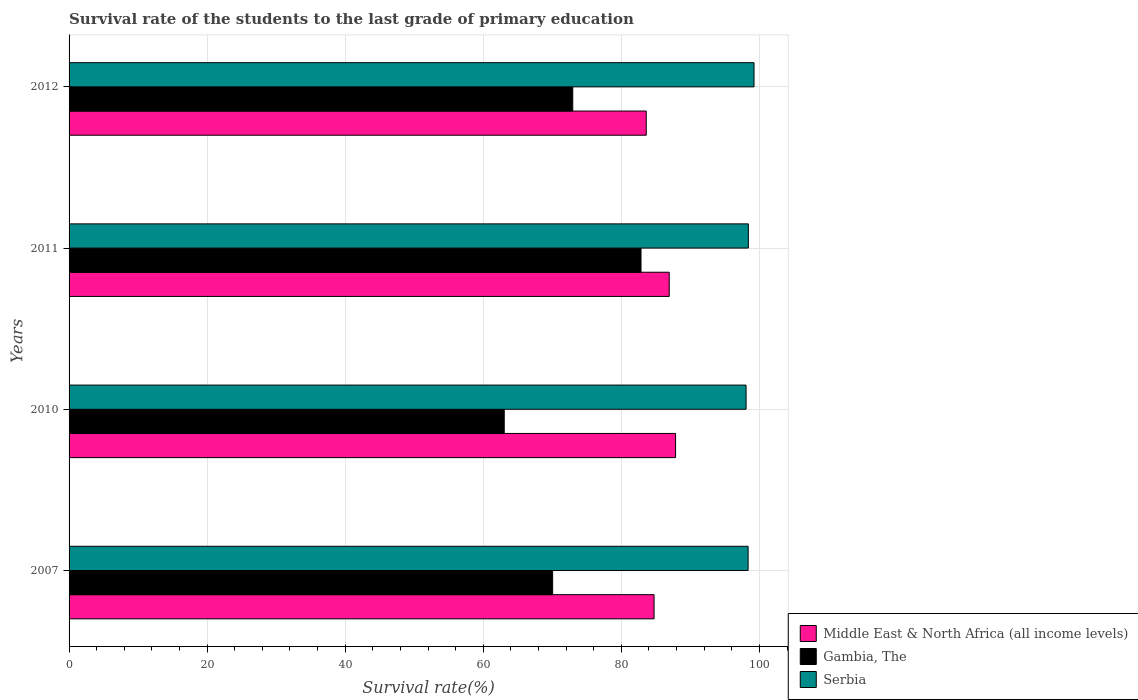How many different coloured bars are there?
Your answer should be very brief. 3. How many groups of bars are there?
Your answer should be very brief. 4. How many bars are there on the 1st tick from the bottom?
Make the answer very short. 3. What is the survival rate of the students in Middle East & North Africa (all income levels) in 2007?
Keep it short and to the point. 84.74. Across all years, what is the maximum survival rate of the students in Middle East & North Africa (all income levels)?
Offer a terse response. 87.86. Across all years, what is the minimum survival rate of the students in Middle East & North Africa (all income levels)?
Provide a short and direct response. 83.61. In which year was the survival rate of the students in Gambia, The maximum?
Your answer should be compact. 2011. In which year was the survival rate of the students in Gambia, The minimum?
Give a very brief answer. 2010. What is the total survival rate of the students in Middle East & North Africa (all income levels) in the graph?
Provide a succinct answer. 343.14. What is the difference between the survival rate of the students in Gambia, The in 2010 and that in 2011?
Provide a short and direct response. -19.81. What is the difference between the survival rate of the students in Serbia in 2011 and the survival rate of the students in Gambia, The in 2007?
Your answer should be compact. 28.35. What is the average survival rate of the students in Gambia, The per year?
Make the answer very short. 72.22. In the year 2007, what is the difference between the survival rate of the students in Middle East & North Africa (all income levels) and survival rate of the students in Gambia, The?
Provide a short and direct response. 14.69. In how many years, is the survival rate of the students in Gambia, The greater than 4 %?
Ensure brevity in your answer.  4. What is the ratio of the survival rate of the students in Middle East & North Africa (all income levels) in 2007 to that in 2010?
Provide a succinct answer. 0.96. What is the difference between the highest and the second highest survival rate of the students in Serbia?
Your answer should be very brief. 0.82. What is the difference between the highest and the lowest survival rate of the students in Middle East & North Africa (all income levels)?
Give a very brief answer. 4.25. In how many years, is the survival rate of the students in Gambia, The greater than the average survival rate of the students in Gambia, The taken over all years?
Provide a succinct answer. 2. Is the sum of the survival rate of the students in Gambia, The in 2011 and 2012 greater than the maximum survival rate of the students in Serbia across all years?
Offer a very short reply. Yes. What does the 3rd bar from the top in 2010 represents?
Make the answer very short. Middle East & North Africa (all income levels). What does the 2nd bar from the bottom in 2010 represents?
Your answer should be very brief. Gambia, The. How many bars are there?
Keep it short and to the point. 12. Are all the bars in the graph horizontal?
Your answer should be very brief. Yes. How many years are there in the graph?
Give a very brief answer. 4. What is the difference between two consecutive major ticks on the X-axis?
Your response must be concise. 20. Does the graph contain any zero values?
Give a very brief answer. No. How many legend labels are there?
Make the answer very short. 3. How are the legend labels stacked?
Your answer should be compact. Vertical. What is the title of the graph?
Provide a succinct answer. Survival rate of the students to the last grade of primary education. What is the label or title of the X-axis?
Offer a terse response. Survival rate(%). What is the Survival rate(%) in Middle East & North Africa (all income levels) in 2007?
Offer a terse response. 84.74. What is the Survival rate(%) in Gambia, The in 2007?
Your response must be concise. 70.05. What is the Survival rate(%) of Serbia in 2007?
Offer a terse response. 98.36. What is the Survival rate(%) of Middle East & North Africa (all income levels) in 2010?
Offer a terse response. 87.86. What is the Survival rate(%) in Gambia, The in 2010?
Keep it short and to the point. 63.04. What is the Survival rate(%) in Serbia in 2010?
Offer a terse response. 98.07. What is the Survival rate(%) of Middle East & North Africa (all income levels) in 2011?
Your response must be concise. 86.94. What is the Survival rate(%) of Gambia, The in 2011?
Provide a succinct answer. 82.85. What is the Survival rate(%) of Serbia in 2011?
Ensure brevity in your answer.  98.4. What is the Survival rate(%) of Middle East & North Africa (all income levels) in 2012?
Your response must be concise. 83.61. What is the Survival rate(%) in Gambia, The in 2012?
Make the answer very short. 72.96. What is the Survival rate(%) in Serbia in 2012?
Provide a short and direct response. 99.22. Across all years, what is the maximum Survival rate(%) of Middle East & North Africa (all income levels)?
Your response must be concise. 87.86. Across all years, what is the maximum Survival rate(%) of Gambia, The?
Give a very brief answer. 82.85. Across all years, what is the maximum Survival rate(%) of Serbia?
Make the answer very short. 99.22. Across all years, what is the minimum Survival rate(%) in Middle East & North Africa (all income levels)?
Your answer should be compact. 83.61. Across all years, what is the minimum Survival rate(%) in Gambia, The?
Offer a very short reply. 63.04. Across all years, what is the minimum Survival rate(%) of Serbia?
Provide a succinct answer. 98.07. What is the total Survival rate(%) in Middle East & North Africa (all income levels) in the graph?
Ensure brevity in your answer.  343.14. What is the total Survival rate(%) in Gambia, The in the graph?
Your response must be concise. 288.89. What is the total Survival rate(%) in Serbia in the graph?
Your answer should be compact. 394.04. What is the difference between the Survival rate(%) of Middle East & North Africa (all income levels) in 2007 and that in 2010?
Provide a succinct answer. -3.11. What is the difference between the Survival rate(%) in Gambia, The in 2007 and that in 2010?
Offer a very short reply. 7.01. What is the difference between the Survival rate(%) of Serbia in 2007 and that in 2010?
Make the answer very short. 0.29. What is the difference between the Survival rate(%) in Middle East & North Africa (all income levels) in 2007 and that in 2011?
Your response must be concise. -2.2. What is the difference between the Survival rate(%) of Gambia, The in 2007 and that in 2011?
Offer a terse response. -12.8. What is the difference between the Survival rate(%) in Serbia in 2007 and that in 2011?
Your answer should be very brief. -0.04. What is the difference between the Survival rate(%) in Middle East & North Africa (all income levels) in 2007 and that in 2012?
Provide a short and direct response. 1.14. What is the difference between the Survival rate(%) in Gambia, The in 2007 and that in 2012?
Your response must be concise. -2.91. What is the difference between the Survival rate(%) in Serbia in 2007 and that in 2012?
Provide a short and direct response. -0.86. What is the difference between the Survival rate(%) in Middle East & North Africa (all income levels) in 2010 and that in 2011?
Your answer should be very brief. 0.92. What is the difference between the Survival rate(%) in Gambia, The in 2010 and that in 2011?
Your response must be concise. -19.81. What is the difference between the Survival rate(%) of Serbia in 2010 and that in 2011?
Your response must be concise. -0.33. What is the difference between the Survival rate(%) in Middle East & North Africa (all income levels) in 2010 and that in 2012?
Offer a very short reply. 4.25. What is the difference between the Survival rate(%) of Gambia, The in 2010 and that in 2012?
Offer a very short reply. -9.92. What is the difference between the Survival rate(%) in Serbia in 2010 and that in 2012?
Offer a terse response. -1.15. What is the difference between the Survival rate(%) in Middle East & North Africa (all income levels) in 2011 and that in 2012?
Ensure brevity in your answer.  3.33. What is the difference between the Survival rate(%) of Gambia, The in 2011 and that in 2012?
Make the answer very short. 9.89. What is the difference between the Survival rate(%) in Serbia in 2011 and that in 2012?
Offer a very short reply. -0.82. What is the difference between the Survival rate(%) of Middle East & North Africa (all income levels) in 2007 and the Survival rate(%) of Gambia, The in 2010?
Make the answer very short. 21.71. What is the difference between the Survival rate(%) of Middle East & North Africa (all income levels) in 2007 and the Survival rate(%) of Serbia in 2010?
Make the answer very short. -13.32. What is the difference between the Survival rate(%) in Gambia, The in 2007 and the Survival rate(%) in Serbia in 2010?
Your answer should be compact. -28.02. What is the difference between the Survival rate(%) in Middle East & North Africa (all income levels) in 2007 and the Survival rate(%) in Gambia, The in 2011?
Your response must be concise. 1.89. What is the difference between the Survival rate(%) in Middle East & North Africa (all income levels) in 2007 and the Survival rate(%) in Serbia in 2011?
Your answer should be compact. -13.66. What is the difference between the Survival rate(%) in Gambia, The in 2007 and the Survival rate(%) in Serbia in 2011?
Your answer should be compact. -28.35. What is the difference between the Survival rate(%) in Middle East & North Africa (all income levels) in 2007 and the Survival rate(%) in Gambia, The in 2012?
Keep it short and to the point. 11.78. What is the difference between the Survival rate(%) in Middle East & North Africa (all income levels) in 2007 and the Survival rate(%) in Serbia in 2012?
Ensure brevity in your answer.  -14.48. What is the difference between the Survival rate(%) of Gambia, The in 2007 and the Survival rate(%) of Serbia in 2012?
Offer a very short reply. -29.17. What is the difference between the Survival rate(%) of Middle East & North Africa (all income levels) in 2010 and the Survival rate(%) of Gambia, The in 2011?
Give a very brief answer. 5.01. What is the difference between the Survival rate(%) of Middle East & North Africa (all income levels) in 2010 and the Survival rate(%) of Serbia in 2011?
Your answer should be compact. -10.54. What is the difference between the Survival rate(%) of Gambia, The in 2010 and the Survival rate(%) of Serbia in 2011?
Keep it short and to the point. -35.36. What is the difference between the Survival rate(%) of Middle East & North Africa (all income levels) in 2010 and the Survival rate(%) of Gambia, The in 2012?
Provide a succinct answer. 14.9. What is the difference between the Survival rate(%) of Middle East & North Africa (all income levels) in 2010 and the Survival rate(%) of Serbia in 2012?
Keep it short and to the point. -11.36. What is the difference between the Survival rate(%) of Gambia, The in 2010 and the Survival rate(%) of Serbia in 2012?
Offer a terse response. -36.18. What is the difference between the Survival rate(%) of Middle East & North Africa (all income levels) in 2011 and the Survival rate(%) of Gambia, The in 2012?
Provide a succinct answer. 13.98. What is the difference between the Survival rate(%) of Middle East & North Africa (all income levels) in 2011 and the Survival rate(%) of Serbia in 2012?
Your response must be concise. -12.28. What is the difference between the Survival rate(%) of Gambia, The in 2011 and the Survival rate(%) of Serbia in 2012?
Your response must be concise. -16.37. What is the average Survival rate(%) in Middle East & North Africa (all income levels) per year?
Provide a short and direct response. 85.79. What is the average Survival rate(%) in Gambia, The per year?
Give a very brief answer. 72.22. What is the average Survival rate(%) in Serbia per year?
Ensure brevity in your answer.  98.51. In the year 2007, what is the difference between the Survival rate(%) in Middle East & North Africa (all income levels) and Survival rate(%) in Gambia, The?
Your response must be concise. 14.69. In the year 2007, what is the difference between the Survival rate(%) in Middle East & North Africa (all income levels) and Survival rate(%) in Serbia?
Ensure brevity in your answer.  -13.62. In the year 2007, what is the difference between the Survival rate(%) in Gambia, The and Survival rate(%) in Serbia?
Give a very brief answer. -28.31. In the year 2010, what is the difference between the Survival rate(%) of Middle East & North Africa (all income levels) and Survival rate(%) of Gambia, The?
Ensure brevity in your answer.  24.82. In the year 2010, what is the difference between the Survival rate(%) in Middle East & North Africa (all income levels) and Survival rate(%) in Serbia?
Provide a short and direct response. -10.21. In the year 2010, what is the difference between the Survival rate(%) in Gambia, The and Survival rate(%) in Serbia?
Your answer should be compact. -35.03. In the year 2011, what is the difference between the Survival rate(%) in Middle East & North Africa (all income levels) and Survival rate(%) in Gambia, The?
Provide a short and direct response. 4.09. In the year 2011, what is the difference between the Survival rate(%) in Middle East & North Africa (all income levels) and Survival rate(%) in Serbia?
Provide a succinct answer. -11.46. In the year 2011, what is the difference between the Survival rate(%) of Gambia, The and Survival rate(%) of Serbia?
Ensure brevity in your answer.  -15.55. In the year 2012, what is the difference between the Survival rate(%) of Middle East & North Africa (all income levels) and Survival rate(%) of Gambia, The?
Offer a very short reply. 10.65. In the year 2012, what is the difference between the Survival rate(%) of Middle East & North Africa (all income levels) and Survival rate(%) of Serbia?
Provide a succinct answer. -15.61. In the year 2012, what is the difference between the Survival rate(%) in Gambia, The and Survival rate(%) in Serbia?
Provide a short and direct response. -26.26. What is the ratio of the Survival rate(%) in Middle East & North Africa (all income levels) in 2007 to that in 2010?
Offer a terse response. 0.96. What is the ratio of the Survival rate(%) in Gambia, The in 2007 to that in 2010?
Keep it short and to the point. 1.11. What is the ratio of the Survival rate(%) in Middle East & North Africa (all income levels) in 2007 to that in 2011?
Provide a succinct answer. 0.97. What is the ratio of the Survival rate(%) of Gambia, The in 2007 to that in 2011?
Ensure brevity in your answer.  0.85. What is the ratio of the Survival rate(%) in Serbia in 2007 to that in 2011?
Provide a succinct answer. 1. What is the ratio of the Survival rate(%) in Middle East & North Africa (all income levels) in 2007 to that in 2012?
Give a very brief answer. 1.01. What is the ratio of the Survival rate(%) in Gambia, The in 2007 to that in 2012?
Your answer should be compact. 0.96. What is the ratio of the Survival rate(%) in Middle East & North Africa (all income levels) in 2010 to that in 2011?
Give a very brief answer. 1.01. What is the ratio of the Survival rate(%) in Gambia, The in 2010 to that in 2011?
Your response must be concise. 0.76. What is the ratio of the Survival rate(%) in Middle East & North Africa (all income levels) in 2010 to that in 2012?
Your answer should be compact. 1.05. What is the ratio of the Survival rate(%) of Gambia, The in 2010 to that in 2012?
Provide a succinct answer. 0.86. What is the ratio of the Survival rate(%) of Serbia in 2010 to that in 2012?
Provide a succinct answer. 0.99. What is the ratio of the Survival rate(%) in Middle East & North Africa (all income levels) in 2011 to that in 2012?
Make the answer very short. 1.04. What is the ratio of the Survival rate(%) in Gambia, The in 2011 to that in 2012?
Your response must be concise. 1.14. What is the ratio of the Survival rate(%) of Serbia in 2011 to that in 2012?
Make the answer very short. 0.99. What is the difference between the highest and the second highest Survival rate(%) in Middle East & North Africa (all income levels)?
Provide a short and direct response. 0.92. What is the difference between the highest and the second highest Survival rate(%) in Gambia, The?
Ensure brevity in your answer.  9.89. What is the difference between the highest and the second highest Survival rate(%) of Serbia?
Provide a short and direct response. 0.82. What is the difference between the highest and the lowest Survival rate(%) of Middle East & North Africa (all income levels)?
Offer a terse response. 4.25. What is the difference between the highest and the lowest Survival rate(%) in Gambia, The?
Ensure brevity in your answer.  19.81. What is the difference between the highest and the lowest Survival rate(%) in Serbia?
Provide a succinct answer. 1.15. 